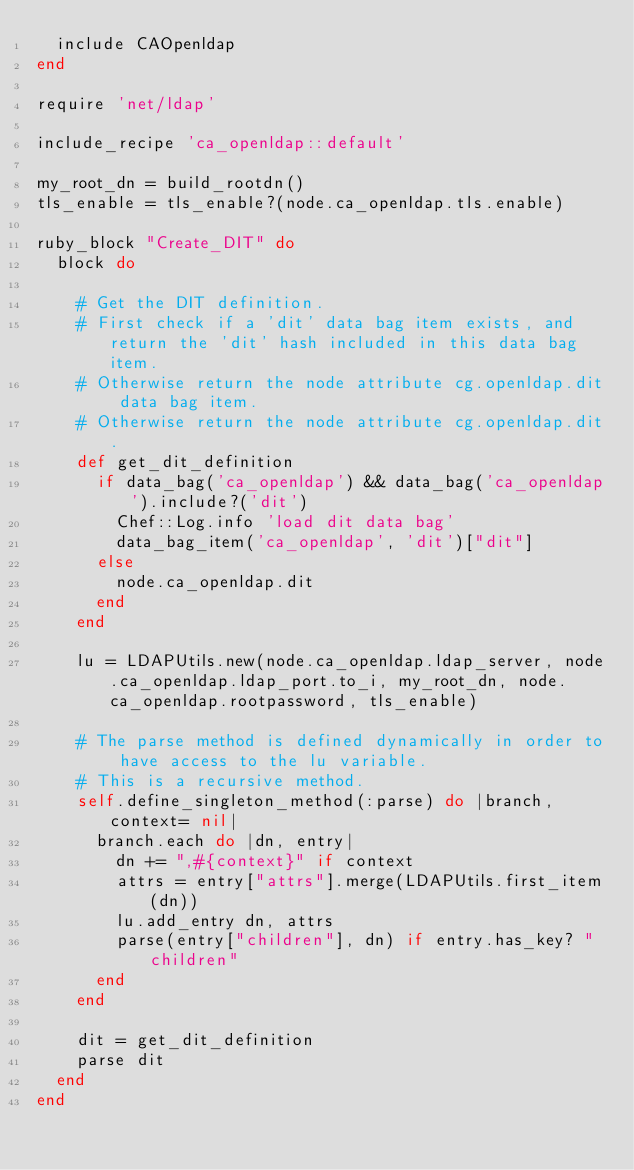Convert code to text. <code><loc_0><loc_0><loc_500><loc_500><_Ruby_>  include CAOpenldap
end

require 'net/ldap'

include_recipe 'ca_openldap::default'

my_root_dn = build_rootdn()
tls_enable = tls_enable?(node.ca_openldap.tls.enable)

ruby_block "Create_DIT" do
  block do 

    # Get the DIT definition.
    # First check if a 'dit' data bag item exists, and return the 'dit' hash included in this data bag item.
    # Otherwise return the node attribute cg.openldap.dit data bag item.
    # Otherwise return the node attribute cg.openldap.dit.  
    def get_dit_definition
      if data_bag('ca_openldap') && data_bag('ca_openldap').include?('dit')
        Chef::Log.info 'load dit data bag'
        data_bag_item('ca_openldap', 'dit')["dit"]
      else
        node.ca_openldap.dit
      end
    end

    lu = LDAPUtils.new(node.ca_openldap.ldap_server, node.ca_openldap.ldap_port.to_i, my_root_dn, node.ca_openldap.rootpassword, tls_enable)

    # The parse method is defined dynamically in order to have access to the lu variable.
    # This is a recursive method.
    self.define_singleton_method(:parse) do |branch, context= nil|
      branch.each do |dn, entry|
        dn += ",#{context}" if context
        attrs = entry["attrs"].merge(LDAPUtils.first_item(dn))
        lu.add_entry dn, attrs
        parse(entry["children"], dn) if entry.has_key? "children"
      end
    end

    dit = get_dit_definition
    parse dit
  end
end
</code> 